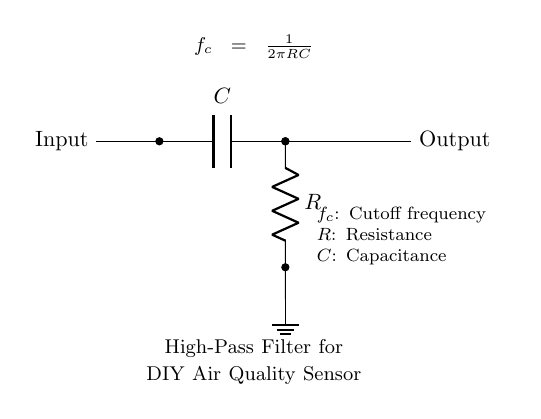What type of filter is this circuit? The circuit diagram represents a high-pass filter, characterized by the capacitor and resistor configuration which allows high-frequency signals to pass through while attenuating low-frequency signals.
Answer: High-pass filter What are the components in this circuit? The components in this circuit include a capacitor labeled C and a resistor labeled R. These two components are connected in a specific configuration that defines the behavior of the filter.
Answer: Capacitor, Resistor What is the output of this circuit called? The output of the circuit is referred to as the output signal, which is taken across the resistor after the input signal has passed through the filter process.
Answer: Output What does the symbol next to the ground represent? The symbol next to the ground signifies that this point in the circuit is connected to the ground level, which serves as the reference point for voltage measurements in the circuit.
Answer: Ground What is the equation shown in the circuit diagram used for? The equation provided calculates the cutoff frequency of the high-pass filter based on the values of resistance (R) and capacitance (C) in the circuit. This frequency is important for understanding which signals will be attenuated or allowed to pass.
Answer: Cutoff frequency At what frequency does this filter start to attenuate signals? The filter begins to attenuate signals at the cutoff frequency identified by the equation, which is determined by the resistance and capacitance values in the circuit.
Answer: Cutoff frequency How do the values of R and C affect the circuit? The values of R and C directly impact the cutoff frequency; increasing either value will lower the cutoff frequency, allowing lower frequencies to pass through, whereas decreasing them will raise the cutoff frequency, allowing higher frequencies.
Answer: Affects cutoff frequency 